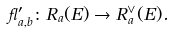<formula> <loc_0><loc_0><loc_500><loc_500>\gamma ^ { \prime } _ { a , b } \colon R _ { a } ( E ) \to R _ { a } ^ { \vee } ( E ) .</formula> 